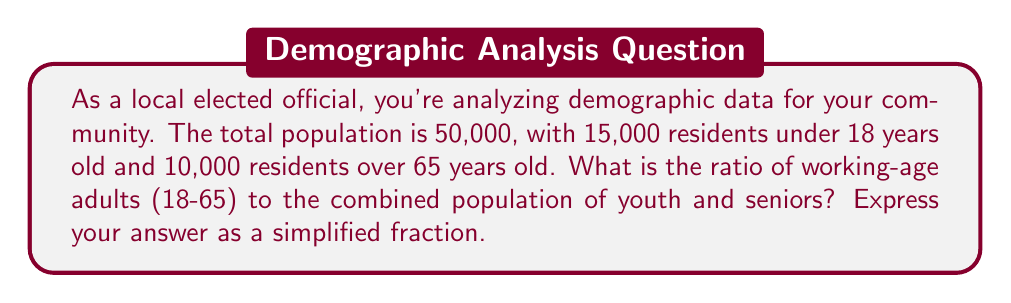What is the answer to this math problem? To solve this problem, let's follow these steps:

1. Calculate the number of working-age adults (18-65):
   Total population = 50,000
   Under 18 = 15,000
   Over 65 = 10,000
   Working-age adults = Total - (Under 18 + Over 65)
   $$ 50,000 - (15,000 + 10,000) = 50,000 - 25,000 = 25,000 $$

2. Calculate the combined population of youth and seniors:
   $$ 15,000 + 10,000 = 25,000 $$

3. Set up the ratio of working-age adults to youth and seniors:
   $$ \frac{\text{Working-age adults}}{\text{Youth and seniors}} = \frac{25,000}{25,000} $$

4. Simplify the ratio:
   $$ \frac{25,000}{25,000} = \frac{1}{1} $$

This simplified ratio tells us that for every 1 person in the combined youth and senior population, there is 1 working-age adult.
Answer: $\frac{1}{1}$ or 1:1 